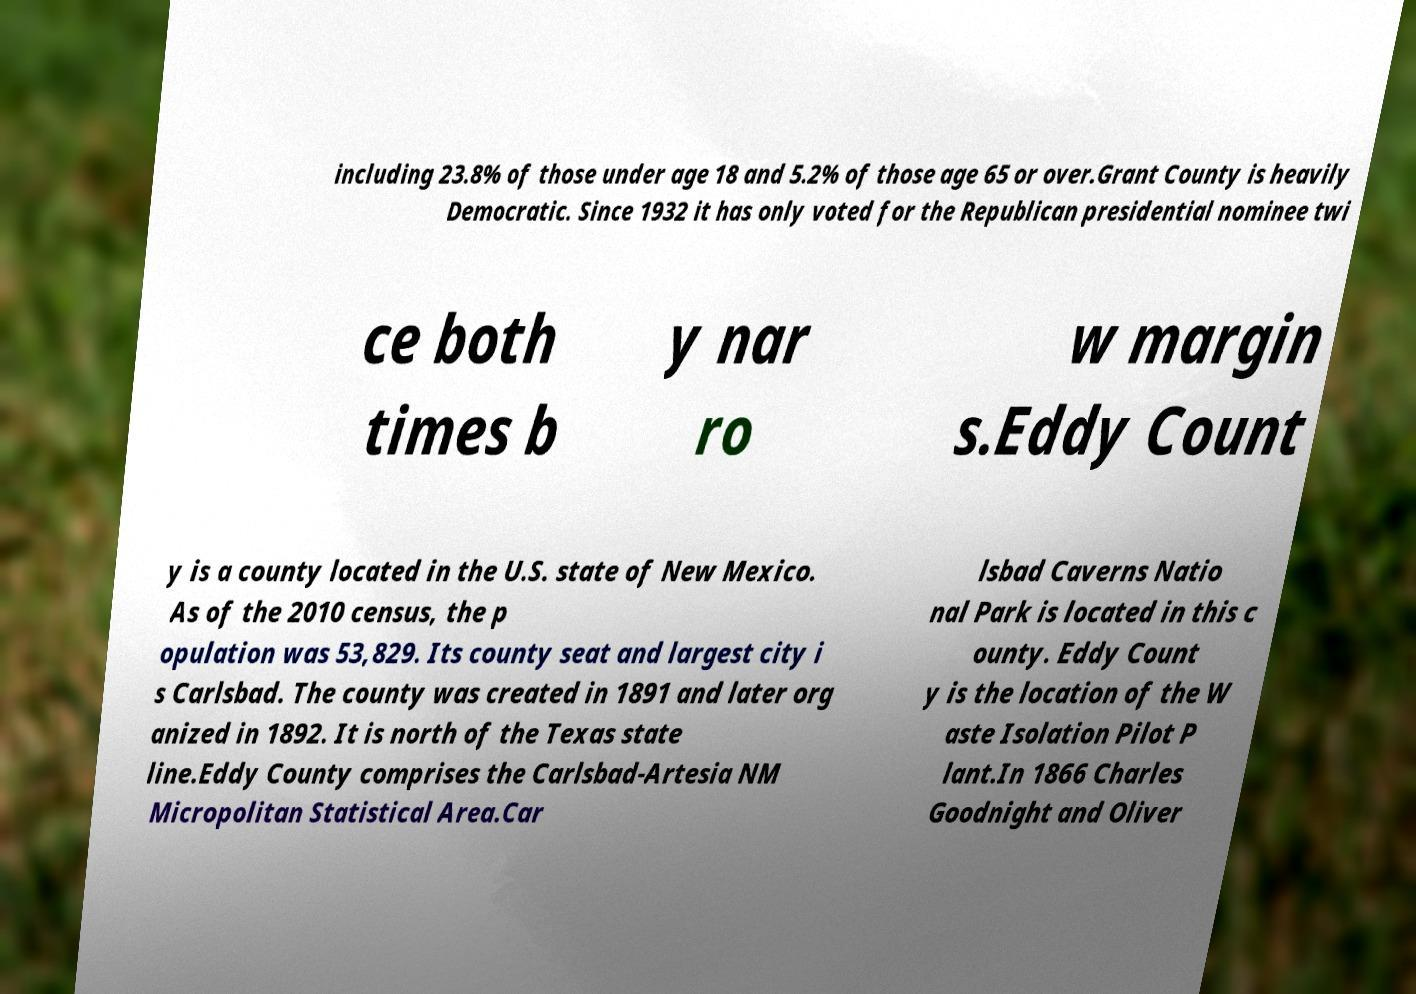Could you assist in decoding the text presented in this image and type it out clearly? including 23.8% of those under age 18 and 5.2% of those age 65 or over.Grant County is heavily Democratic. Since 1932 it has only voted for the Republican presidential nominee twi ce both times b y nar ro w margin s.Eddy Count y is a county located in the U.S. state of New Mexico. As of the 2010 census, the p opulation was 53,829. Its county seat and largest city i s Carlsbad. The county was created in 1891 and later org anized in 1892. It is north of the Texas state line.Eddy County comprises the Carlsbad-Artesia NM Micropolitan Statistical Area.Car lsbad Caverns Natio nal Park is located in this c ounty. Eddy Count y is the location of the W aste Isolation Pilot P lant.In 1866 Charles Goodnight and Oliver 